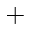<formula> <loc_0><loc_0><loc_500><loc_500>+</formula> 